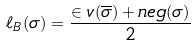<formula> <loc_0><loc_0><loc_500><loc_500>\ell _ { B } ( \sigma ) = \frac { \in v ( \overline { \sigma } ) + n e g ( \sigma ) } { 2 }</formula> 